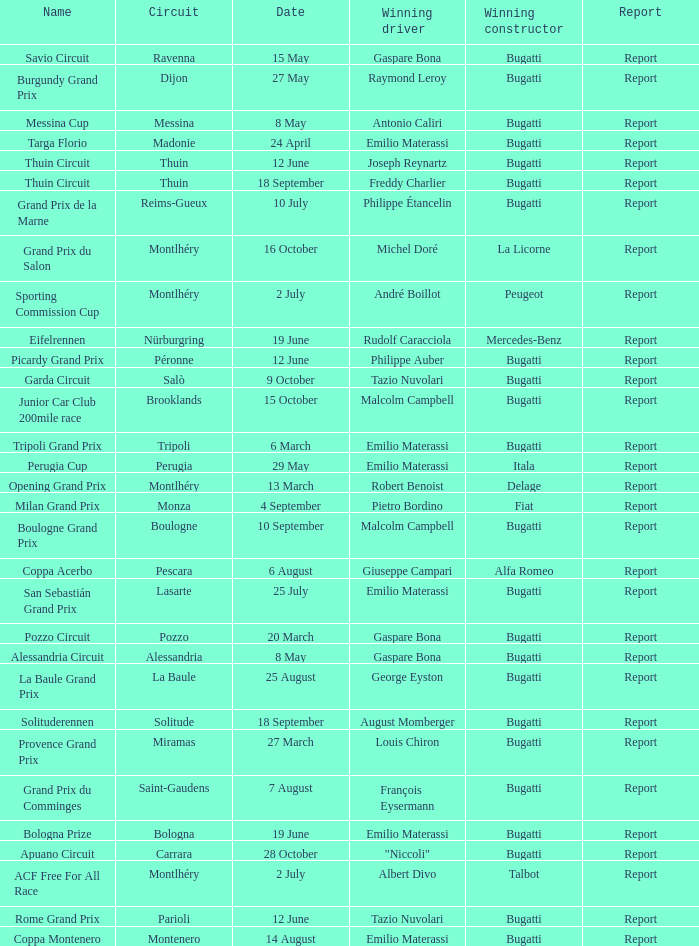Who was the winning constructor at the circuit of parioli? Bugatti. 